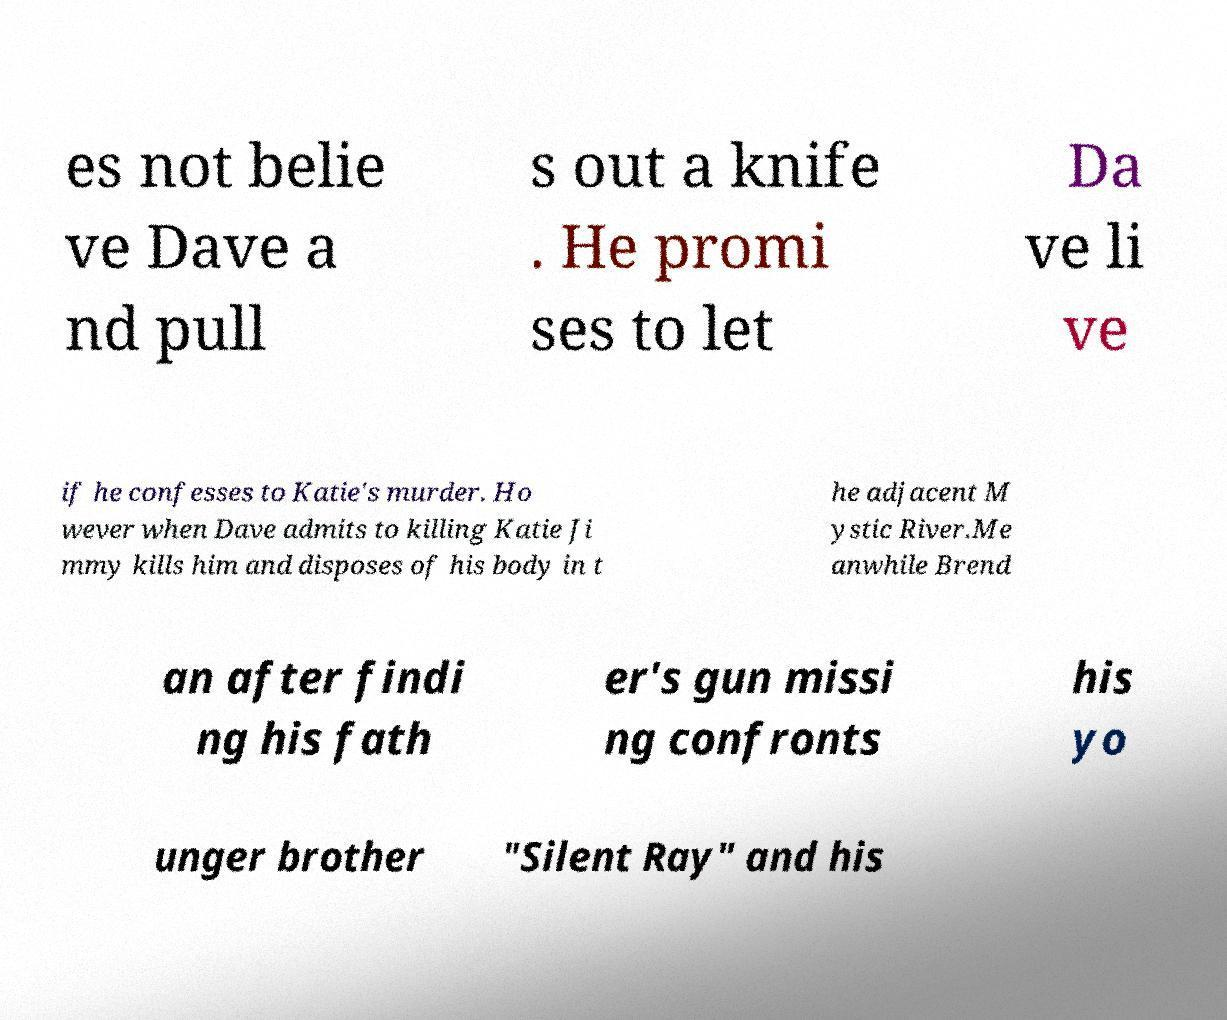Please identify and transcribe the text found in this image. es not belie ve Dave a nd pull s out a knife . He promi ses to let Da ve li ve if he confesses to Katie's murder. Ho wever when Dave admits to killing Katie Ji mmy kills him and disposes of his body in t he adjacent M ystic River.Me anwhile Brend an after findi ng his fath er's gun missi ng confronts his yo unger brother "Silent Ray" and his 